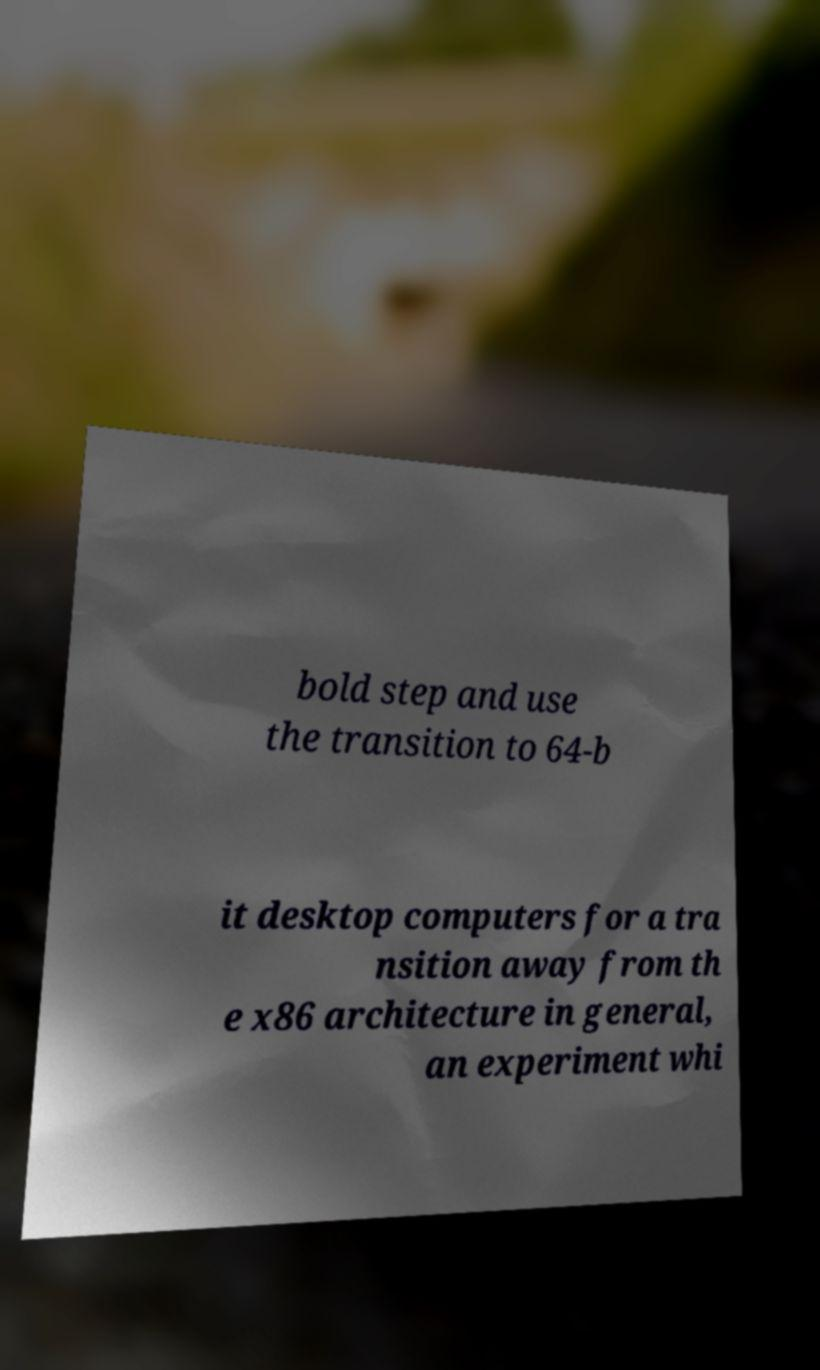Could you extract and type out the text from this image? bold step and use the transition to 64-b it desktop computers for a tra nsition away from th e x86 architecture in general, an experiment whi 